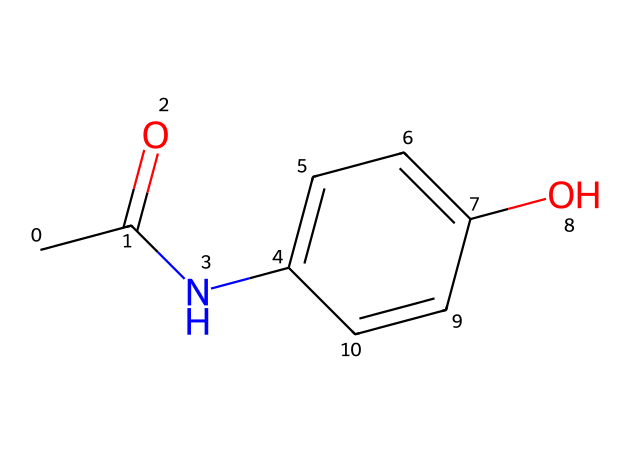What is the molecular formula of paracetamol? By analyzing the SMILES notation, CC(=O)Nc1ccc(O)cc1, we can identify the constituents: there are 8 carbon atoms (C), 9 hydrogen atoms (H), 1 nitrogen atom (N), and 2 oxygen atoms (O). This leads us to the molecular formula C8H9NO2.
Answer: C8H9NO2 How many rings are present in the structure of paracetamol? In the provided SMILES, "c" indicates aromatic carbon atoms, and observing the connectivity reveals there is only one cyclic structure (the benzene-like ring). Upon inspection, no additional rings are detected.
Answer: 1 What type of functional group is present in paracetamol? The functional groups in the structure are an amide (due to the -N and carbonyl group) and a hydroxyl (–OH) group, but considering the key ones, the presence of the amide group is significant for its properties.
Answer: amide Which substituent is attached to the para position of the aromatic ring in paracetamol? In the aromatic ring system shown, the hydroxyl group (–OH) is positioned opposite to the carbonyl-amine structure which indicates it is at the para position relative to the -NHCOCH3 substituent. Thus, we identify the para substituent as the hydroxyl group.
Answer: hydroxyl How does the presence of the hydroxyl group influence the solubility of paracetamol? The hydroxyl group is polar and can form hydrogen bonds with water molecules, which enhances solubility in aqueous environments, thereby aiding in the effectiveness of paracetamol as a drug. This is particularly true for compounds with a balance of hydrophobic (the aromatic part) and hydrophilic (the hydroxyl group) characteristics.
Answer: enhances solubility What is the total number of hydrogen bonds in the paracetamol structure? Analyzing the structure reveals that the hydroxyl group (–OH) can act as a hydrogen bond donor, while the nitrogen in the amide group can act as both a donor and acceptor. However, the exact count can vary based on molecular interactions in a solution, but observing the structure, there is potential for three key hydrogen bonds from the hydroxyl and amide nitrogen.
Answer: 3 